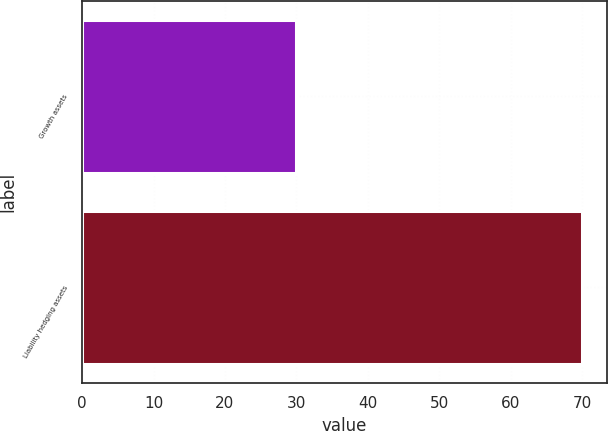Convert chart to OTSL. <chart><loc_0><loc_0><loc_500><loc_500><bar_chart><fcel>Growth assets<fcel>Liability hedging assets<nl><fcel>30<fcel>70<nl></chart> 